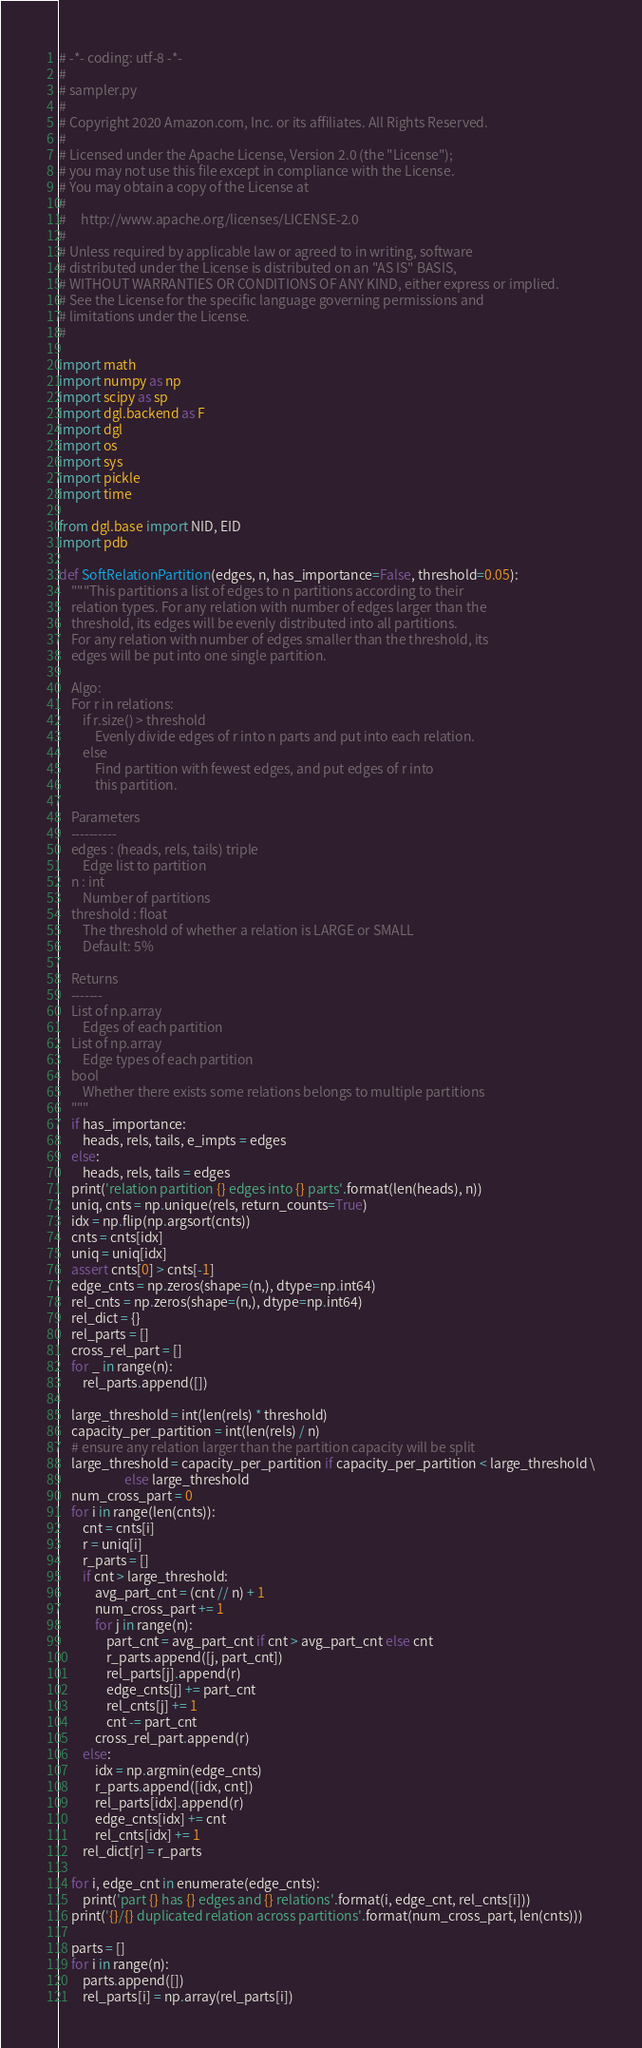Convert code to text. <code><loc_0><loc_0><loc_500><loc_500><_Python_># -*- coding: utf-8 -*-
#
# sampler.py
#
# Copyright 2020 Amazon.com, Inc. or its affiliates. All Rights Reserved.
#
# Licensed under the Apache License, Version 2.0 (the "License");
# you may not use this file except in compliance with the License.
# You may obtain a copy of the License at
#
#     http://www.apache.org/licenses/LICENSE-2.0
#
# Unless required by applicable law or agreed to in writing, software
# distributed under the License is distributed on an "AS IS" BASIS,
# WITHOUT WARRANTIES OR CONDITIONS OF ANY KIND, either express or implied.
# See the License for the specific language governing permissions and
# limitations under the License.
#

import math
import numpy as np
import scipy as sp
import dgl.backend as F
import dgl
import os
import sys
import pickle
import time

from dgl.base import NID, EID
import pdb

def SoftRelationPartition(edges, n, has_importance=False, threshold=0.05):
    """This partitions a list of edges to n partitions according to their
    relation types. For any relation with number of edges larger than the
    threshold, its edges will be evenly distributed into all partitions.
    For any relation with number of edges smaller than the threshold, its
    edges will be put into one single partition.

    Algo:
    For r in relations:
        if r.size() > threshold
            Evenly divide edges of r into n parts and put into each relation.
        else
            Find partition with fewest edges, and put edges of r into
            this partition.

    Parameters
    ----------
    edges : (heads, rels, tails) triple
        Edge list to partition
    n : int
        Number of partitions
    threshold : float
        The threshold of whether a relation is LARGE or SMALL
        Default: 5%

    Returns
    -------
    List of np.array
        Edges of each partition
    List of np.array
        Edge types of each partition
    bool
        Whether there exists some relations belongs to multiple partitions
    """
    if has_importance:
        heads, rels, tails, e_impts = edges
    else:
        heads, rels, tails = edges
    print('relation partition {} edges into {} parts'.format(len(heads), n))
    uniq, cnts = np.unique(rels, return_counts=True)
    idx = np.flip(np.argsort(cnts))
    cnts = cnts[idx]
    uniq = uniq[idx]
    assert cnts[0] > cnts[-1]
    edge_cnts = np.zeros(shape=(n,), dtype=np.int64)
    rel_cnts = np.zeros(shape=(n,), dtype=np.int64)
    rel_dict = {}
    rel_parts = []
    cross_rel_part = []
    for _ in range(n):
        rel_parts.append([])

    large_threshold = int(len(rels) * threshold)
    capacity_per_partition = int(len(rels) / n)
    # ensure any relation larger than the partition capacity will be split
    large_threshold = capacity_per_partition if capacity_per_partition < large_threshold \
                      else large_threshold
    num_cross_part = 0
    for i in range(len(cnts)):
        cnt = cnts[i]
        r = uniq[i]
        r_parts = []
        if cnt > large_threshold:
            avg_part_cnt = (cnt // n) + 1
            num_cross_part += 1
            for j in range(n):
                part_cnt = avg_part_cnt if cnt > avg_part_cnt else cnt
                r_parts.append([j, part_cnt])
                rel_parts[j].append(r)
                edge_cnts[j] += part_cnt
                rel_cnts[j] += 1
                cnt -= part_cnt
            cross_rel_part.append(r)
        else:
            idx = np.argmin(edge_cnts)
            r_parts.append([idx, cnt])
            rel_parts[idx].append(r)
            edge_cnts[idx] += cnt
            rel_cnts[idx] += 1
        rel_dict[r] = r_parts

    for i, edge_cnt in enumerate(edge_cnts):
        print('part {} has {} edges and {} relations'.format(i, edge_cnt, rel_cnts[i]))
    print('{}/{} duplicated relation across partitions'.format(num_cross_part, len(cnts)))

    parts = []
    for i in range(n):
        parts.append([])
        rel_parts[i] = np.array(rel_parts[i])
</code> 